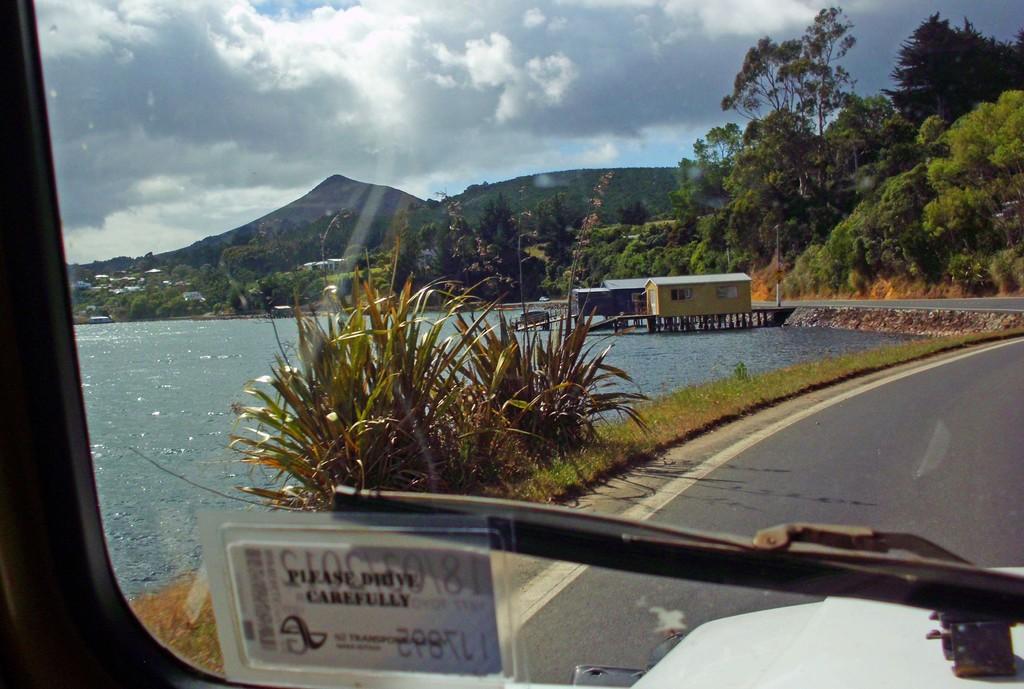Can you describe this image briefly? A vehicle is moving on a road. There are many trees and water lake. This is the plant and grass. The sky is sunny and cloudy 